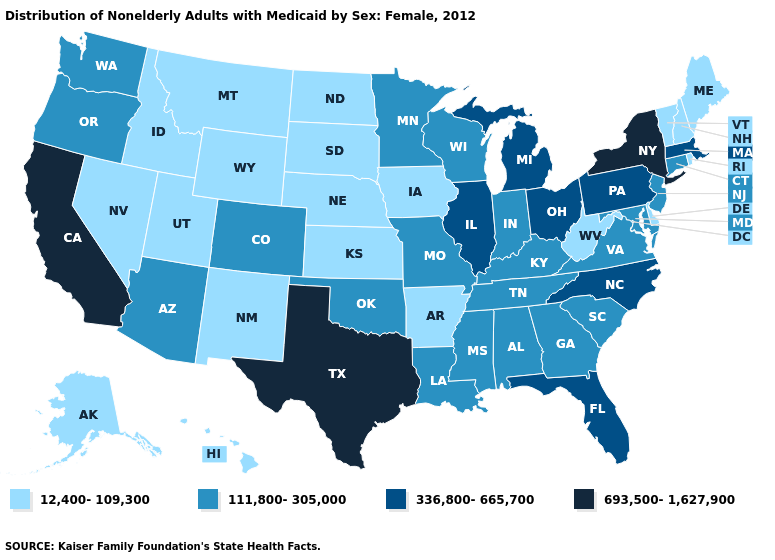What is the lowest value in the Northeast?
Quick response, please. 12,400-109,300. Does New York have the highest value in the USA?
Give a very brief answer. Yes. Does Texas have the highest value in the South?
Quick response, please. Yes. Name the states that have a value in the range 693,500-1,627,900?
Keep it brief. California, New York, Texas. Does New Mexico have the same value as Missouri?
Give a very brief answer. No. Among the states that border Oklahoma , which have the lowest value?
Concise answer only. Arkansas, Kansas, New Mexico. Does Virginia have the same value as Wyoming?
Give a very brief answer. No. What is the highest value in states that border Tennessee?
Keep it brief. 336,800-665,700. Which states hav the highest value in the Northeast?
Write a very short answer. New York. Does Montana have a lower value than Louisiana?
Quick response, please. Yes. What is the value of South Carolina?
Quick response, please. 111,800-305,000. Name the states that have a value in the range 12,400-109,300?
Be succinct. Alaska, Arkansas, Delaware, Hawaii, Idaho, Iowa, Kansas, Maine, Montana, Nebraska, Nevada, New Hampshire, New Mexico, North Dakota, Rhode Island, South Dakota, Utah, Vermont, West Virginia, Wyoming. Name the states that have a value in the range 693,500-1,627,900?
Answer briefly. California, New York, Texas. How many symbols are there in the legend?
Short answer required. 4. 